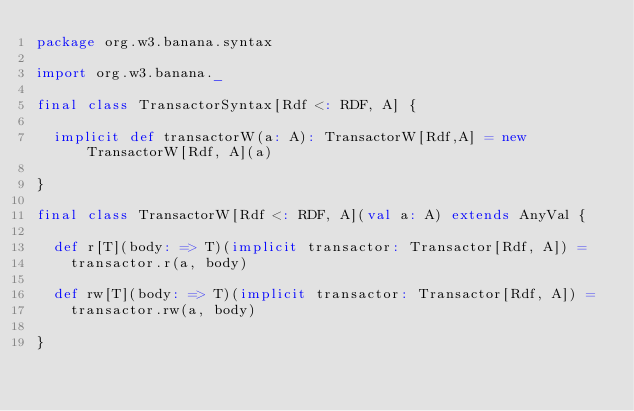Convert code to text. <code><loc_0><loc_0><loc_500><loc_500><_Scala_>package org.w3.banana.syntax

import org.w3.banana._

final class TransactorSyntax[Rdf <: RDF, A] {

  implicit def transactorW(a: A): TransactorW[Rdf,A] = new TransactorW[Rdf, A](a)

}

final class TransactorW[Rdf <: RDF, A](val a: A) extends AnyVal {

  def r[T](body: => T)(implicit transactor: Transactor[Rdf, A]) =
    transactor.r(a, body)

  def rw[T](body: => T)(implicit transactor: Transactor[Rdf, A]) =
    transactor.rw(a, body)

}
</code> 